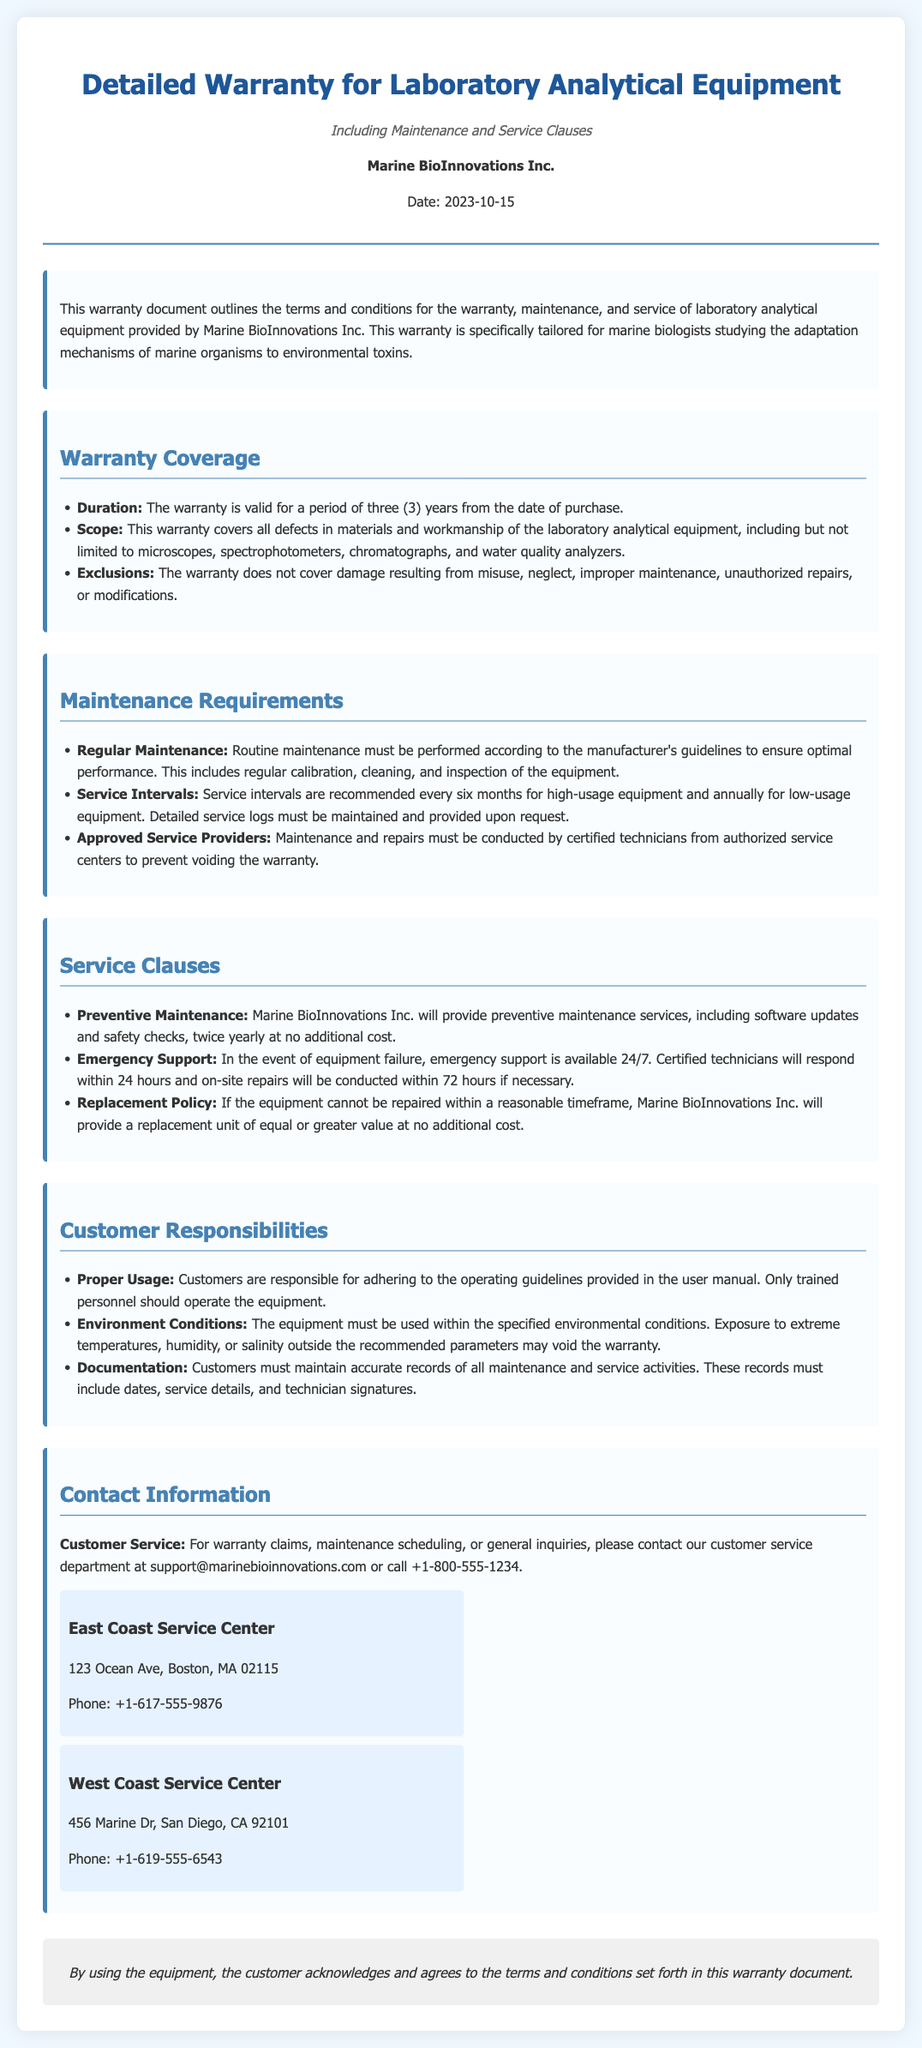What is the company name? The company name is mentioned in the header of the document.
Answer: Marine BioInnovations Inc What is the warranty duration? The warranty duration is specified under the Warranty Coverage section.
Answer: three (3) years What type of equipment does the warranty cover? The scope of warranty coverage lists the types of equipment included.
Answer: microscopes, spectrophotometers, chromatographs, and water quality analyzers How often must routine maintenance be performed? The Maintenance Requirements section provides the frequency of routine maintenance.
Answer: according to the manufacturer's guidelines What is the emergency support response time? The Service Clauses section outlines the response time for emergency support.
Answer: within 24 hours What is an exclusion under the warranty? Exclusions for the warranty are detailed in the Warranty Coverage section.
Answer: misuse, neglect, improper maintenance, unauthorized repairs, or modifications How frequently are preventive maintenance services provided? The preventive maintenance services frequency is listed in the service clauses.
Answer: twice yearly Who should perform maintenance to avoid voiding the warranty? The Maintenance Requirements section specifies who should conduct maintenance.
Answer: certified technicians from authorized service centers What contact email is provided for customer service? The Contact Information section includes the email for customer service inquiries.
Answer: support@marinebioinnovations.com 